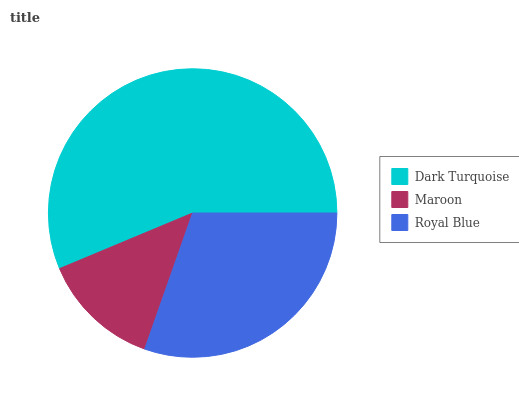Is Maroon the minimum?
Answer yes or no. Yes. Is Dark Turquoise the maximum?
Answer yes or no. Yes. Is Royal Blue the minimum?
Answer yes or no. No. Is Royal Blue the maximum?
Answer yes or no. No. Is Royal Blue greater than Maroon?
Answer yes or no. Yes. Is Maroon less than Royal Blue?
Answer yes or no. Yes. Is Maroon greater than Royal Blue?
Answer yes or no. No. Is Royal Blue less than Maroon?
Answer yes or no. No. Is Royal Blue the high median?
Answer yes or no. Yes. Is Royal Blue the low median?
Answer yes or no. Yes. Is Dark Turquoise the high median?
Answer yes or no. No. Is Dark Turquoise the low median?
Answer yes or no. No. 